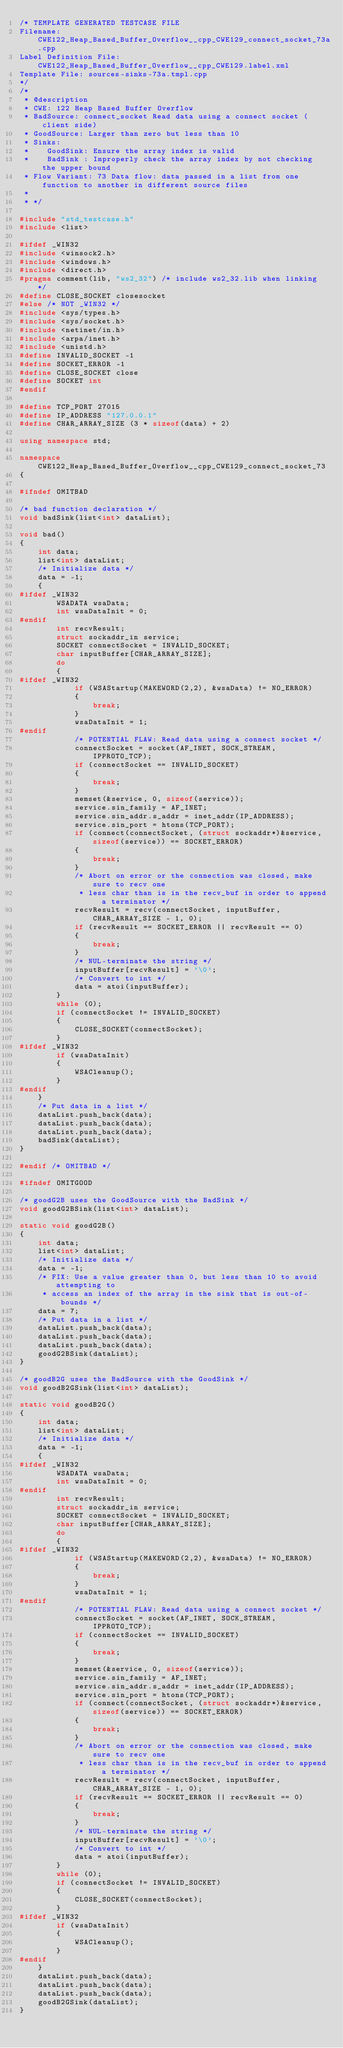Convert code to text. <code><loc_0><loc_0><loc_500><loc_500><_C++_>/* TEMPLATE GENERATED TESTCASE FILE
Filename: CWE122_Heap_Based_Buffer_Overflow__cpp_CWE129_connect_socket_73a.cpp
Label Definition File: CWE122_Heap_Based_Buffer_Overflow__cpp_CWE129.label.xml
Template File: sources-sinks-73a.tmpl.cpp
*/
/*
 * @description
 * CWE: 122 Heap Based Buffer Overflow
 * BadSource: connect_socket Read data using a connect socket (client side)
 * GoodSource: Larger than zero but less than 10
 * Sinks:
 *    GoodSink: Ensure the array index is valid
 *    BadSink : Improperly check the array index by not checking the upper bound
 * Flow Variant: 73 Data flow: data passed in a list from one function to another in different source files
 *
 * */

#include "std_testcase.h"
#include <list>

#ifdef _WIN32
#include <winsock2.h>
#include <windows.h>
#include <direct.h>
#pragma comment(lib, "ws2_32") /* include ws2_32.lib when linking */
#define CLOSE_SOCKET closesocket
#else /* NOT _WIN32 */
#include <sys/types.h>
#include <sys/socket.h>
#include <netinet/in.h>
#include <arpa/inet.h>
#include <unistd.h>
#define INVALID_SOCKET -1
#define SOCKET_ERROR -1
#define CLOSE_SOCKET close
#define SOCKET int
#endif

#define TCP_PORT 27015
#define IP_ADDRESS "127.0.0.1"
#define CHAR_ARRAY_SIZE (3 * sizeof(data) + 2)

using namespace std;

namespace CWE122_Heap_Based_Buffer_Overflow__cpp_CWE129_connect_socket_73
{

#ifndef OMITBAD

/* bad function declaration */
void badSink(list<int> dataList);

void bad()
{
    int data;
    list<int> dataList;
    /* Initialize data */
    data = -1;
    {
#ifdef _WIN32
        WSADATA wsaData;
        int wsaDataInit = 0;
#endif
        int recvResult;
        struct sockaddr_in service;
        SOCKET connectSocket = INVALID_SOCKET;
        char inputBuffer[CHAR_ARRAY_SIZE];
        do
        {
#ifdef _WIN32
            if (WSAStartup(MAKEWORD(2,2), &wsaData) != NO_ERROR)
            {
                break;
            }
            wsaDataInit = 1;
#endif
            /* POTENTIAL FLAW: Read data using a connect socket */
            connectSocket = socket(AF_INET, SOCK_STREAM, IPPROTO_TCP);
            if (connectSocket == INVALID_SOCKET)
            {
                break;
            }
            memset(&service, 0, sizeof(service));
            service.sin_family = AF_INET;
            service.sin_addr.s_addr = inet_addr(IP_ADDRESS);
            service.sin_port = htons(TCP_PORT);
            if (connect(connectSocket, (struct sockaddr*)&service, sizeof(service)) == SOCKET_ERROR)
            {
                break;
            }
            /* Abort on error or the connection was closed, make sure to recv one
             * less char than is in the recv_buf in order to append a terminator */
            recvResult = recv(connectSocket, inputBuffer, CHAR_ARRAY_SIZE - 1, 0);
            if (recvResult == SOCKET_ERROR || recvResult == 0)
            {
                break;
            }
            /* NUL-terminate the string */
            inputBuffer[recvResult] = '\0';
            /* Convert to int */
            data = atoi(inputBuffer);
        }
        while (0);
        if (connectSocket != INVALID_SOCKET)
        {
            CLOSE_SOCKET(connectSocket);
        }
#ifdef _WIN32
        if (wsaDataInit)
        {
            WSACleanup();
        }
#endif
    }
    /* Put data in a list */
    dataList.push_back(data);
    dataList.push_back(data);
    dataList.push_back(data);
    badSink(dataList);
}

#endif /* OMITBAD */

#ifndef OMITGOOD

/* goodG2B uses the GoodSource with the BadSink */
void goodG2BSink(list<int> dataList);

static void goodG2B()
{
    int data;
    list<int> dataList;
    /* Initialize data */
    data = -1;
    /* FIX: Use a value greater than 0, but less than 10 to avoid attempting to
     * access an index of the array in the sink that is out-of-bounds */
    data = 7;
    /* Put data in a list */
    dataList.push_back(data);
    dataList.push_back(data);
    dataList.push_back(data);
    goodG2BSink(dataList);
}

/* goodB2G uses the BadSource with the GoodSink */
void goodB2GSink(list<int> dataList);

static void goodB2G()
{
    int data;
    list<int> dataList;
    /* Initialize data */
    data = -1;
    {
#ifdef _WIN32
        WSADATA wsaData;
        int wsaDataInit = 0;
#endif
        int recvResult;
        struct sockaddr_in service;
        SOCKET connectSocket = INVALID_SOCKET;
        char inputBuffer[CHAR_ARRAY_SIZE];
        do
        {
#ifdef _WIN32
            if (WSAStartup(MAKEWORD(2,2), &wsaData) != NO_ERROR)
            {
                break;
            }
            wsaDataInit = 1;
#endif
            /* POTENTIAL FLAW: Read data using a connect socket */
            connectSocket = socket(AF_INET, SOCK_STREAM, IPPROTO_TCP);
            if (connectSocket == INVALID_SOCKET)
            {
                break;
            }
            memset(&service, 0, sizeof(service));
            service.sin_family = AF_INET;
            service.sin_addr.s_addr = inet_addr(IP_ADDRESS);
            service.sin_port = htons(TCP_PORT);
            if (connect(connectSocket, (struct sockaddr*)&service, sizeof(service)) == SOCKET_ERROR)
            {
                break;
            }
            /* Abort on error or the connection was closed, make sure to recv one
             * less char than is in the recv_buf in order to append a terminator */
            recvResult = recv(connectSocket, inputBuffer, CHAR_ARRAY_SIZE - 1, 0);
            if (recvResult == SOCKET_ERROR || recvResult == 0)
            {
                break;
            }
            /* NUL-terminate the string */
            inputBuffer[recvResult] = '\0';
            /* Convert to int */
            data = atoi(inputBuffer);
        }
        while (0);
        if (connectSocket != INVALID_SOCKET)
        {
            CLOSE_SOCKET(connectSocket);
        }
#ifdef _WIN32
        if (wsaDataInit)
        {
            WSACleanup();
        }
#endif
    }
    dataList.push_back(data);
    dataList.push_back(data);
    dataList.push_back(data);
    goodB2GSink(dataList);
}
</code> 